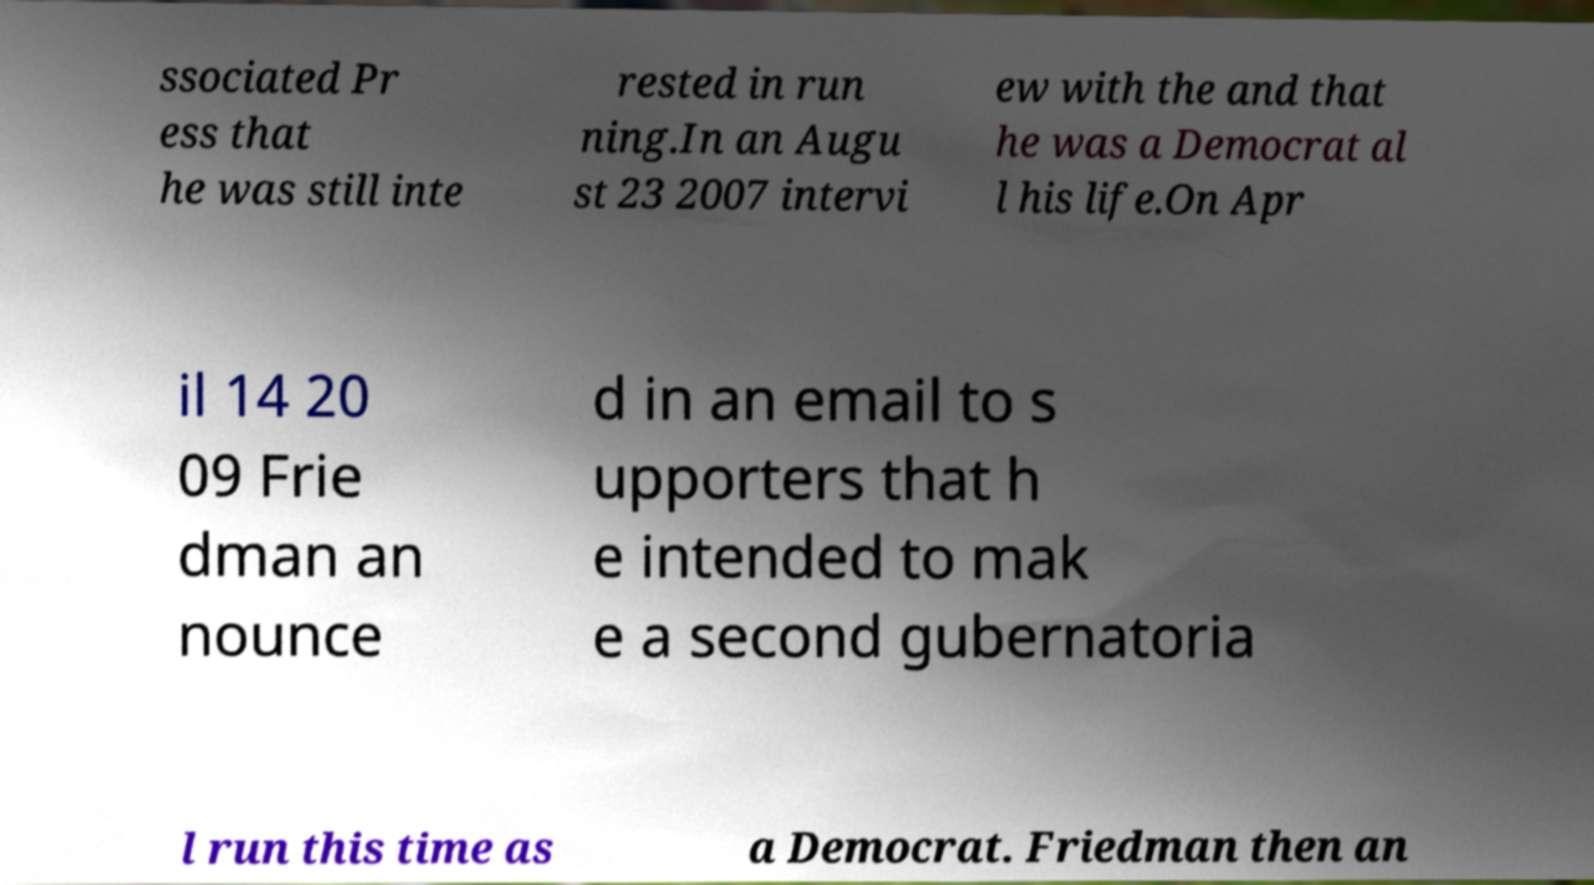I need the written content from this picture converted into text. Can you do that? ssociated Pr ess that he was still inte rested in run ning.In an Augu st 23 2007 intervi ew with the and that he was a Democrat al l his life.On Apr il 14 20 09 Frie dman an nounce d in an email to s upporters that h e intended to mak e a second gubernatoria l run this time as a Democrat. Friedman then an 